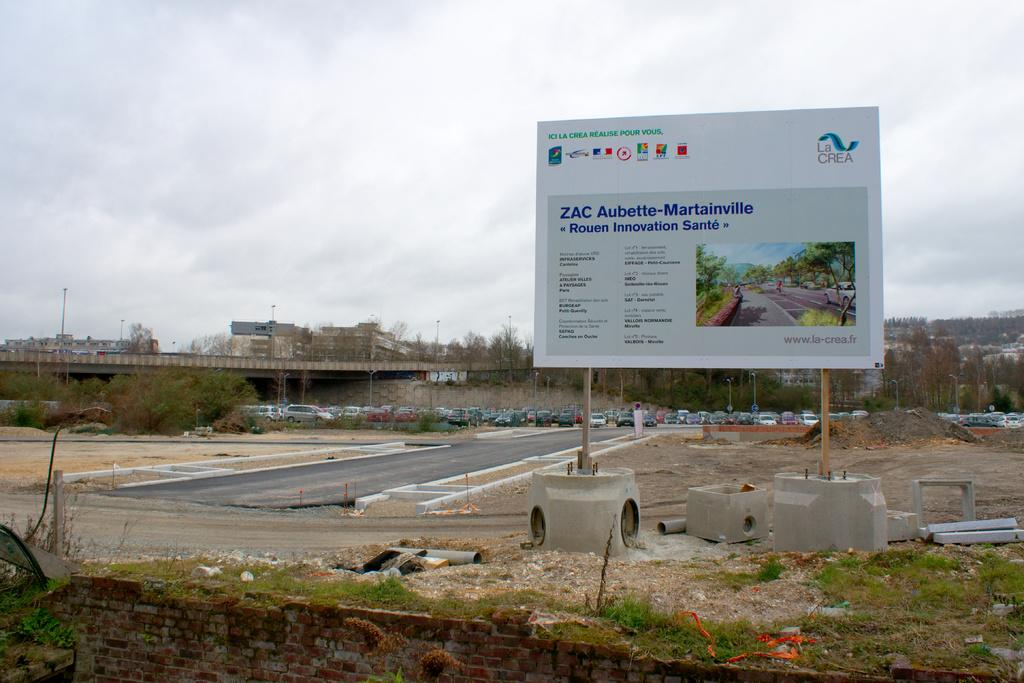<image>
Offer a succinct explanation of the picture presented. the word aubette that is on a white sign 